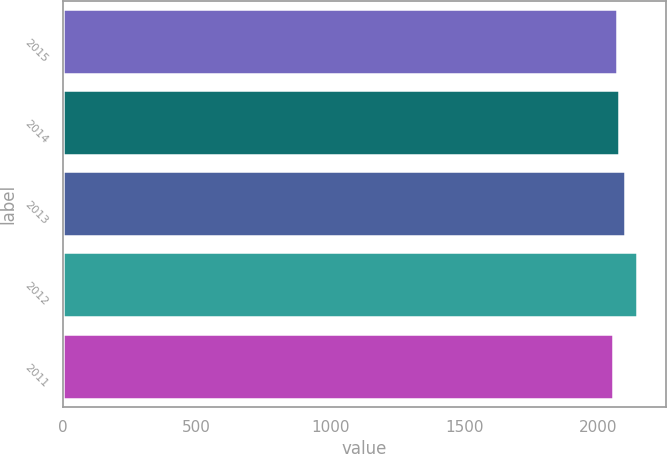Convert chart. <chart><loc_0><loc_0><loc_500><loc_500><bar_chart><fcel>2015<fcel>2014<fcel>2013<fcel>2012<fcel>2011<nl><fcel>2068<fcel>2078<fcel>2101<fcel>2145<fcel>2056<nl></chart> 